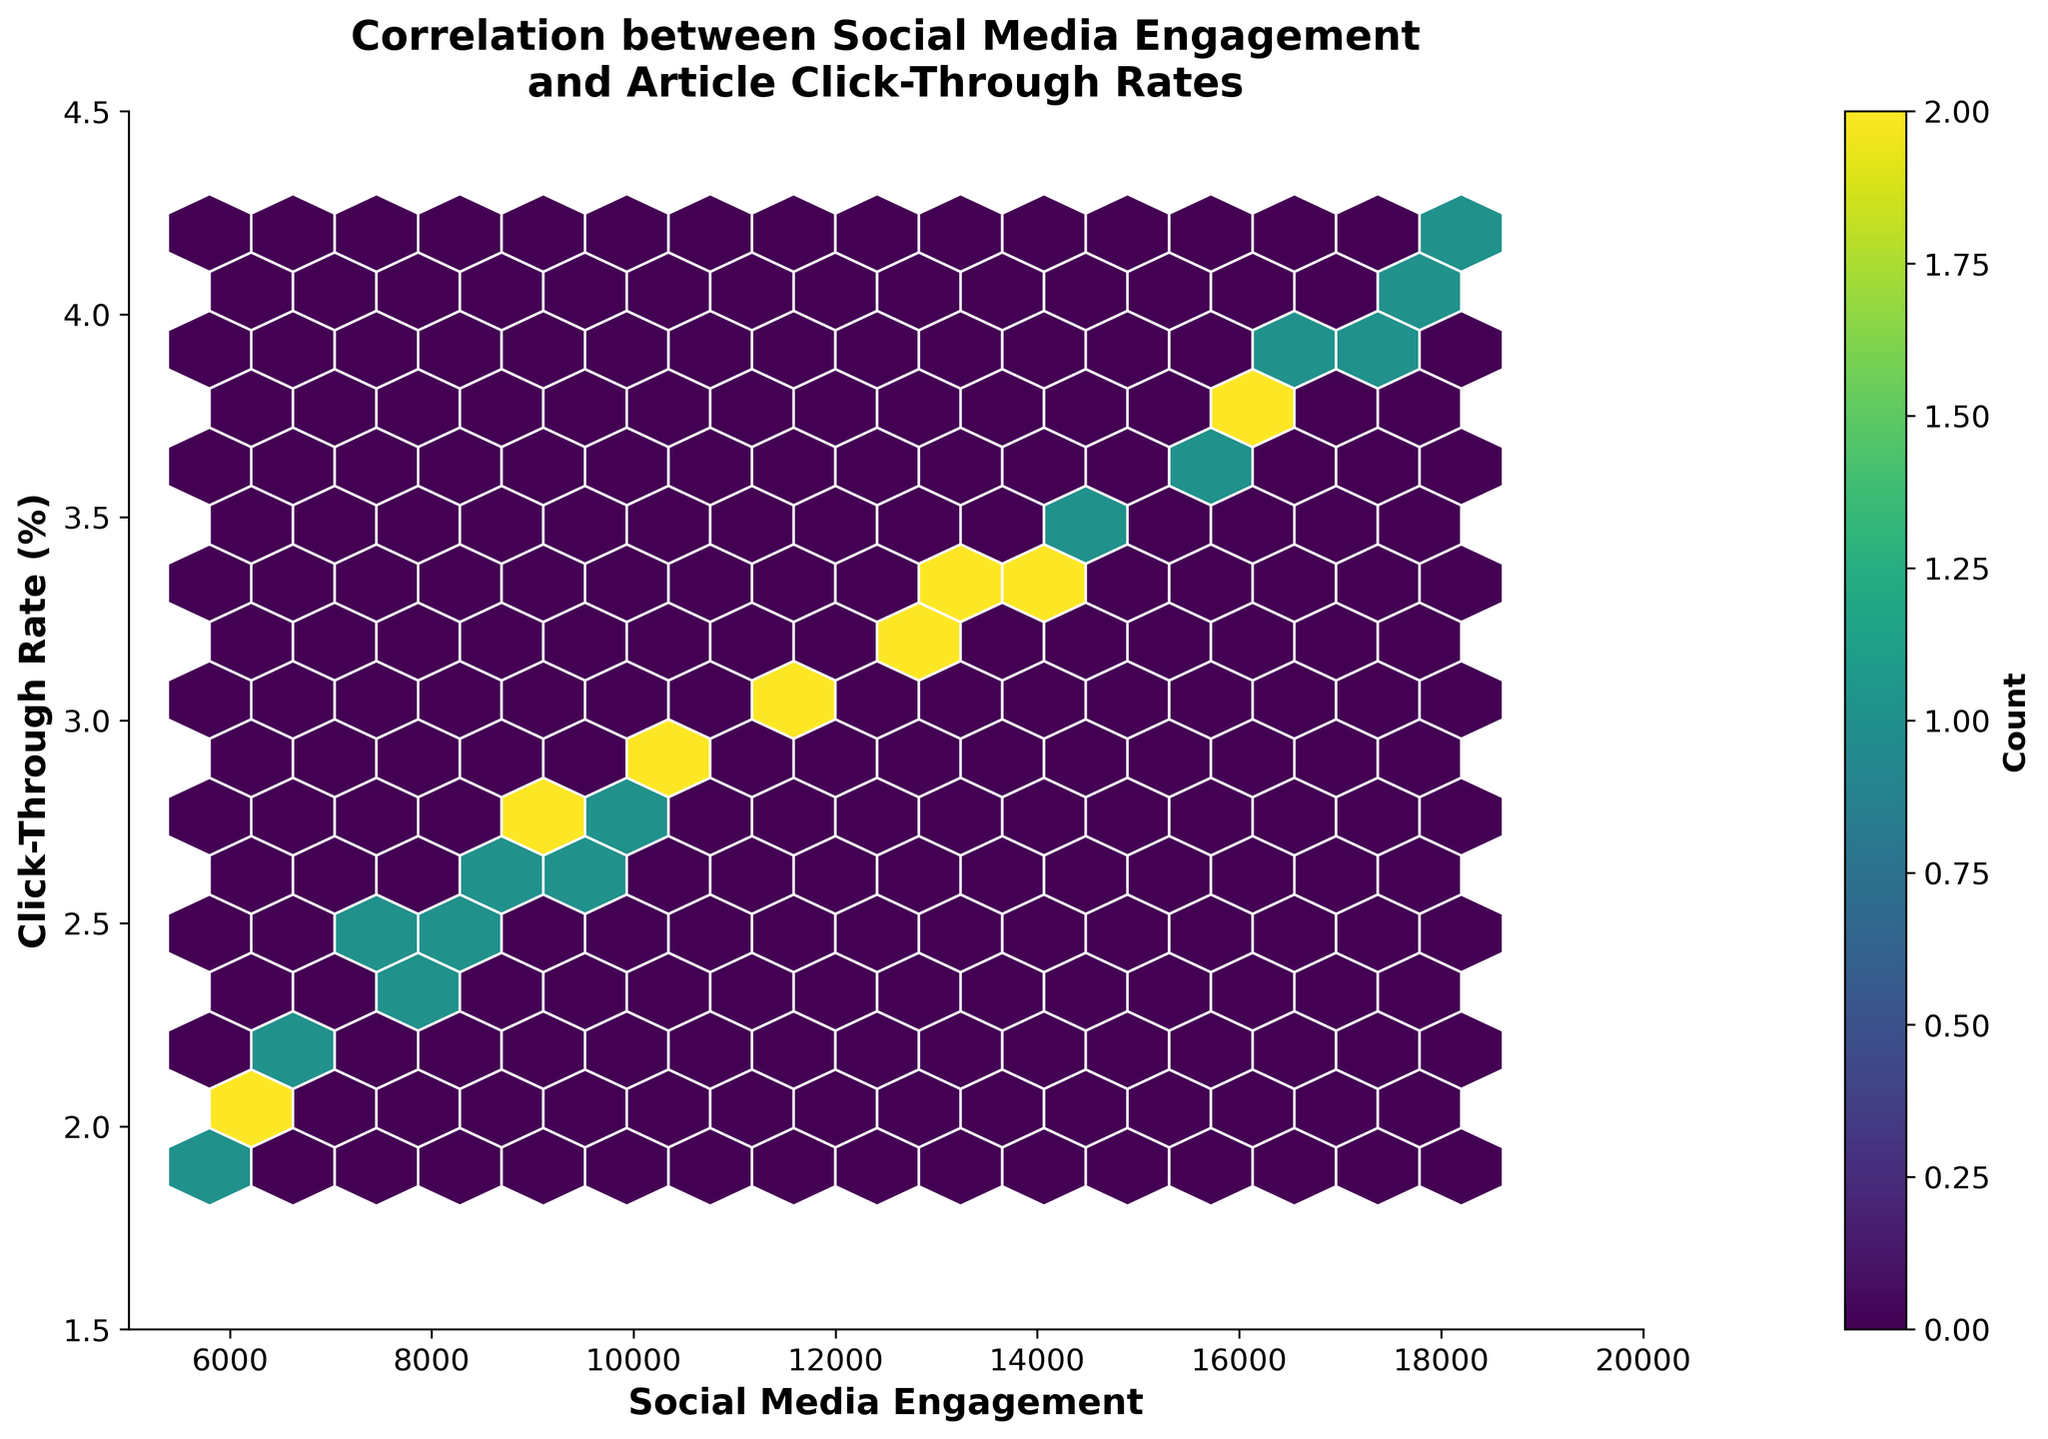How many axes are there in the figure? The figure shows two axes: one for Social Media Engagement on the x-axis and one for Click-Through Rate (%) on the y-axis.
Answer: 2 What are the minimum and maximum values of the x-axis? The x-axis represents Social Media Engagement and ranges from 5000 to 20000.
Answer: 5000, 20000 What is the color used to denote the highest count of data points in the hexbin plot? The color varies in a viridis colormap, with the highest count of data points likely represented by the darker shades of color.
Answer: Darkest shades What is the title of the hexbin plot? The title of the hexbin plot is "Correlation between Social Media Engagement\nand Article Click-Through Rates."
Answer: Correlation between Social Media Engagement\nand Article Click-Through Rates Which axis has the label 'Click-Through Rate (%),' and what size is the font? The y-axis has the label 'Click-Through Rate (%),' and the font size used is 14.
Answer: y-axis, 14 What is the range of the y-axis in the plot? The y-axis, representing the Click-Through Rate (%), ranges from 1.5 to 4.5.
Answer: 1.5, 4.5 How many bins does the hexbin plot show? The number of bins in the hexbin plot is specified by the gridsize parameter in the code, which is set to 15.
Answer: 15 What is on the colorbar? The colorbar represents the count of data points within each hexbin. It has the label 'Count' and uses the viridis colormap.
Answer: Count Is there more density of data points at higher social media engagement levels or lower social media engagement levels? The density of data points appears to be higher at higher social media engagement levels as indicated by the concentration of darker-colored bins in those areas.
Answer: Higher How is the correlation between social media engagement and article click-through rates visually represented in the hexbin plot? The correlation is visually represented by the overall distribution and density patterns of the hexagons, showing how closely related the social media engagement values are to click-through rates. The trend shows that higher social media engagement tends to be associated with higher click-through rates.
Answer: Positive correlation 